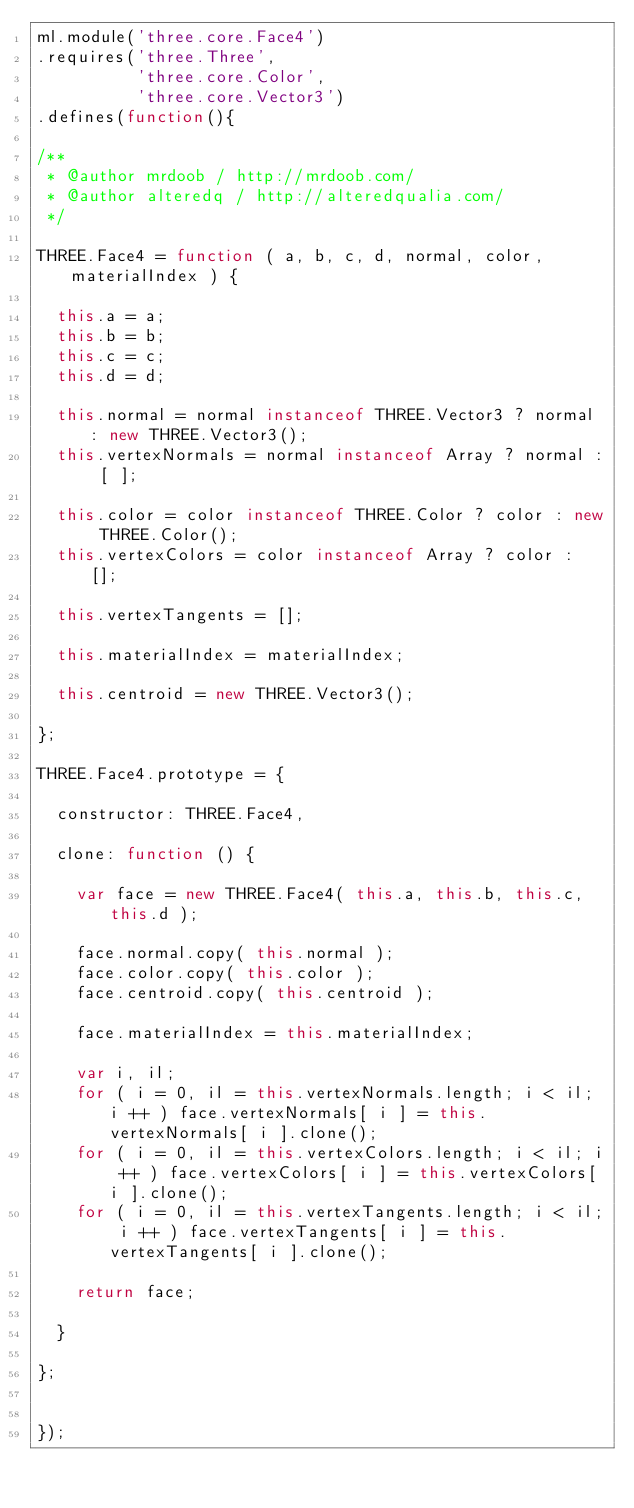<code> <loc_0><loc_0><loc_500><loc_500><_JavaScript_>ml.module('three.core.Face4')
.requires('three.Three',
          'three.core.Color',
          'three.core.Vector3')
.defines(function(){

/**
 * @author mrdoob / http://mrdoob.com/
 * @author alteredq / http://alteredqualia.com/
 */

THREE.Face4 = function ( a, b, c, d, normal, color, materialIndex ) {

	this.a = a;
	this.b = b;
	this.c = c;
	this.d = d;

	this.normal = normal instanceof THREE.Vector3 ? normal : new THREE.Vector3();
	this.vertexNormals = normal instanceof Array ? normal : [ ];

	this.color = color instanceof THREE.Color ? color : new THREE.Color();
	this.vertexColors = color instanceof Array ? color : [];

	this.vertexTangents = [];

	this.materialIndex = materialIndex;

	this.centroid = new THREE.Vector3();

};

THREE.Face4.prototype = {

	constructor: THREE.Face4,

	clone: function () {

		var face = new THREE.Face4( this.a, this.b, this.c, this.d );

		face.normal.copy( this.normal );
		face.color.copy( this.color );
		face.centroid.copy( this.centroid );

		face.materialIndex = this.materialIndex;

		var i, il;
		for ( i = 0, il = this.vertexNormals.length; i < il; i ++ ) face.vertexNormals[ i ] = this.vertexNormals[ i ].clone();
		for ( i = 0, il = this.vertexColors.length; i < il; i ++ ) face.vertexColors[ i ] = this.vertexColors[ i ].clone();
		for ( i = 0, il = this.vertexTangents.length; i < il; i ++ ) face.vertexTangents[ i ] = this.vertexTangents[ i ].clone();

		return face;

	}

};


});</code> 